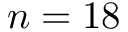<formula> <loc_0><loc_0><loc_500><loc_500>n = 1 8</formula> 